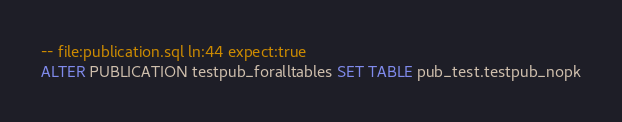<code> <loc_0><loc_0><loc_500><loc_500><_SQL_>-- file:publication.sql ln:44 expect:true
ALTER PUBLICATION testpub_foralltables SET TABLE pub_test.testpub_nopk
</code> 